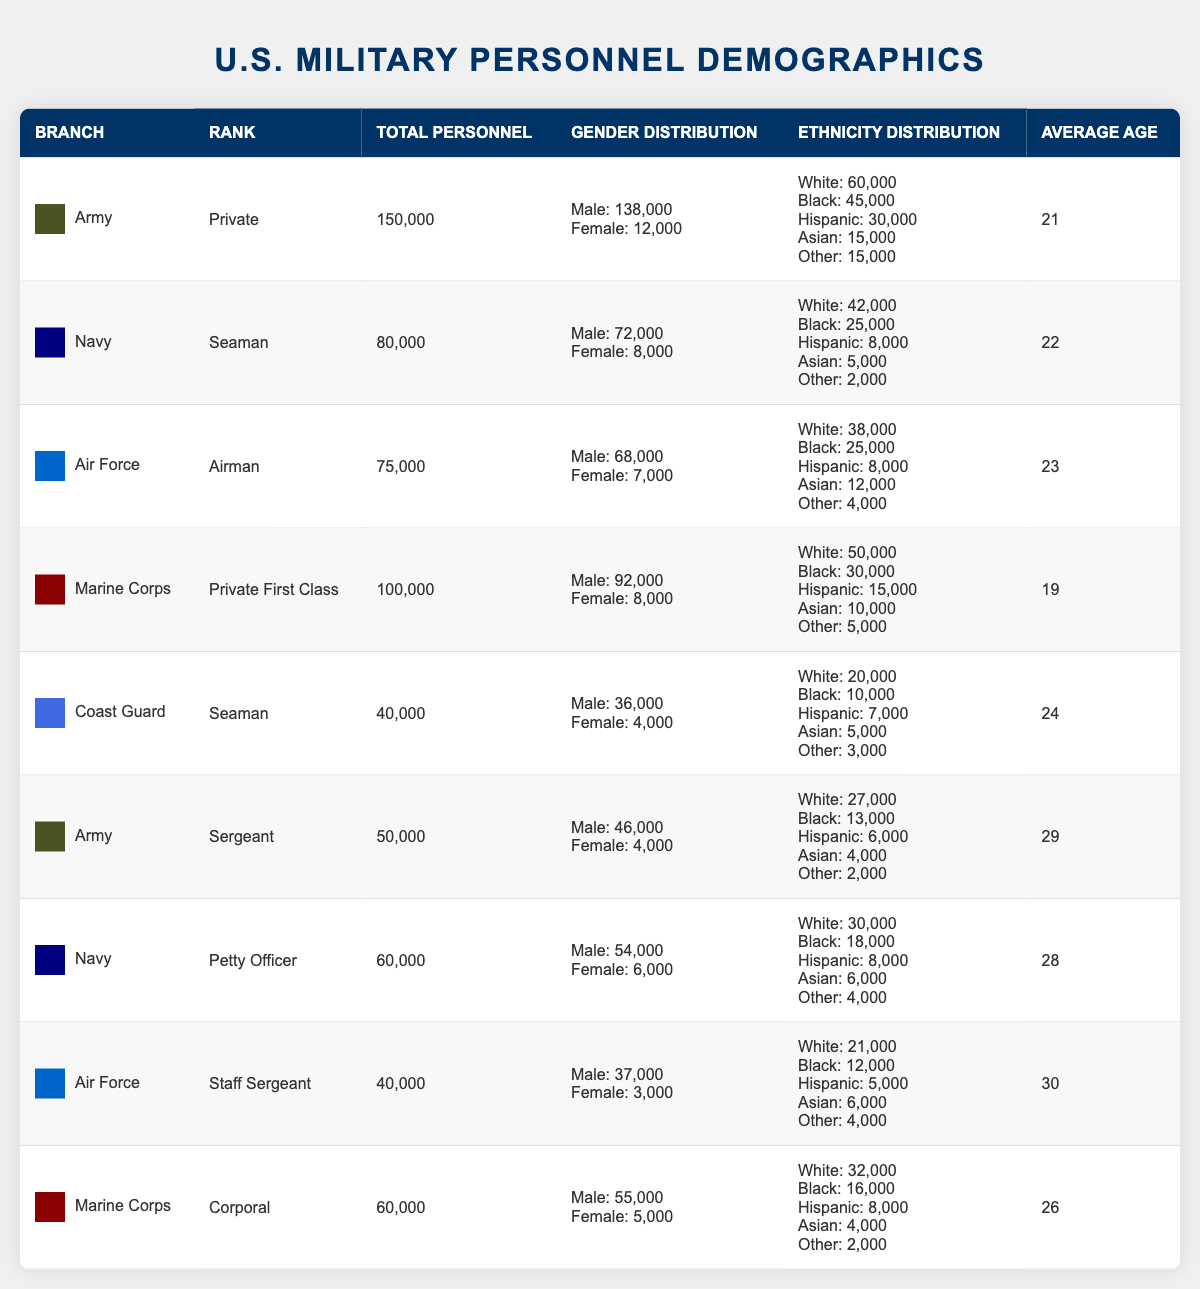What is the total number of Army personnel? The table shows the Army rank of Private with a total of 150,000 personnel and Sergeant with 50,000 personnel. Adding these together gives 150,000 + 50,000 = 200,000.
Answer: 200,000 Which branch has the highest average age among its personnel? The average ages by branch are: Army (25), Navy (25), Air Force (26), Marine Corps (23.5), and Coast Guard (24). The highest average age is for the Air Force at 30.
Answer: Air Force Is the total number of male personnel in the Navy greater than that in the Coast Guard? The Navy has 72,000 male personnel while the Coast Guard has 36,000. Comparing these numbers, 72,000 is greater than 36,000.
Answer: Yes What percentage of Air Force personnel are female? The total number of Air Force personnel is 75,000, and the number of female personnel is 7,000. To find the percentage, the calculation is (7,000 / 75,000) * 100 = 9.33%.
Answer: 9.33% What is the total number of Black personnel across all branches? The total number of Black personnel is calculated as follows: Army (45,000) + Navy (25,000) + Air Force (25,000) + Marine Corps (30,000) + Coast Guard (10,000) = 135,000.
Answer: 135,000 Does the Marine Corps have a higher total number of Corporal personnel than the Navy's Petty Officer? Marine Corps has 60,000 Corporals and the Navy has 60,000 Petty Officers. Since both numbers are equal, the Marine Corps does not have more.
Answer: No Which branch has the lowest average age, and what is that age? Reviewing the average ages, the Marine Corps (Private First Class) has the lowest average age of 19.
Answer: Marine Corps, 19 How many more male personnel does the Army have compared to the Air Force? The Army has 138,000 male personnel and the Air Force has 68,000. The difference is 138,000 - 68,000 = 70,000.
Answer: 70,000 What is the ratio of male to female personnel in the Army for the Private rank? For the Army's Private rank, there are 138,000 males and 12,000 females. The ratio is 138,000:12,000, which simplifies to 11.5:1.
Answer: 11.5:1 